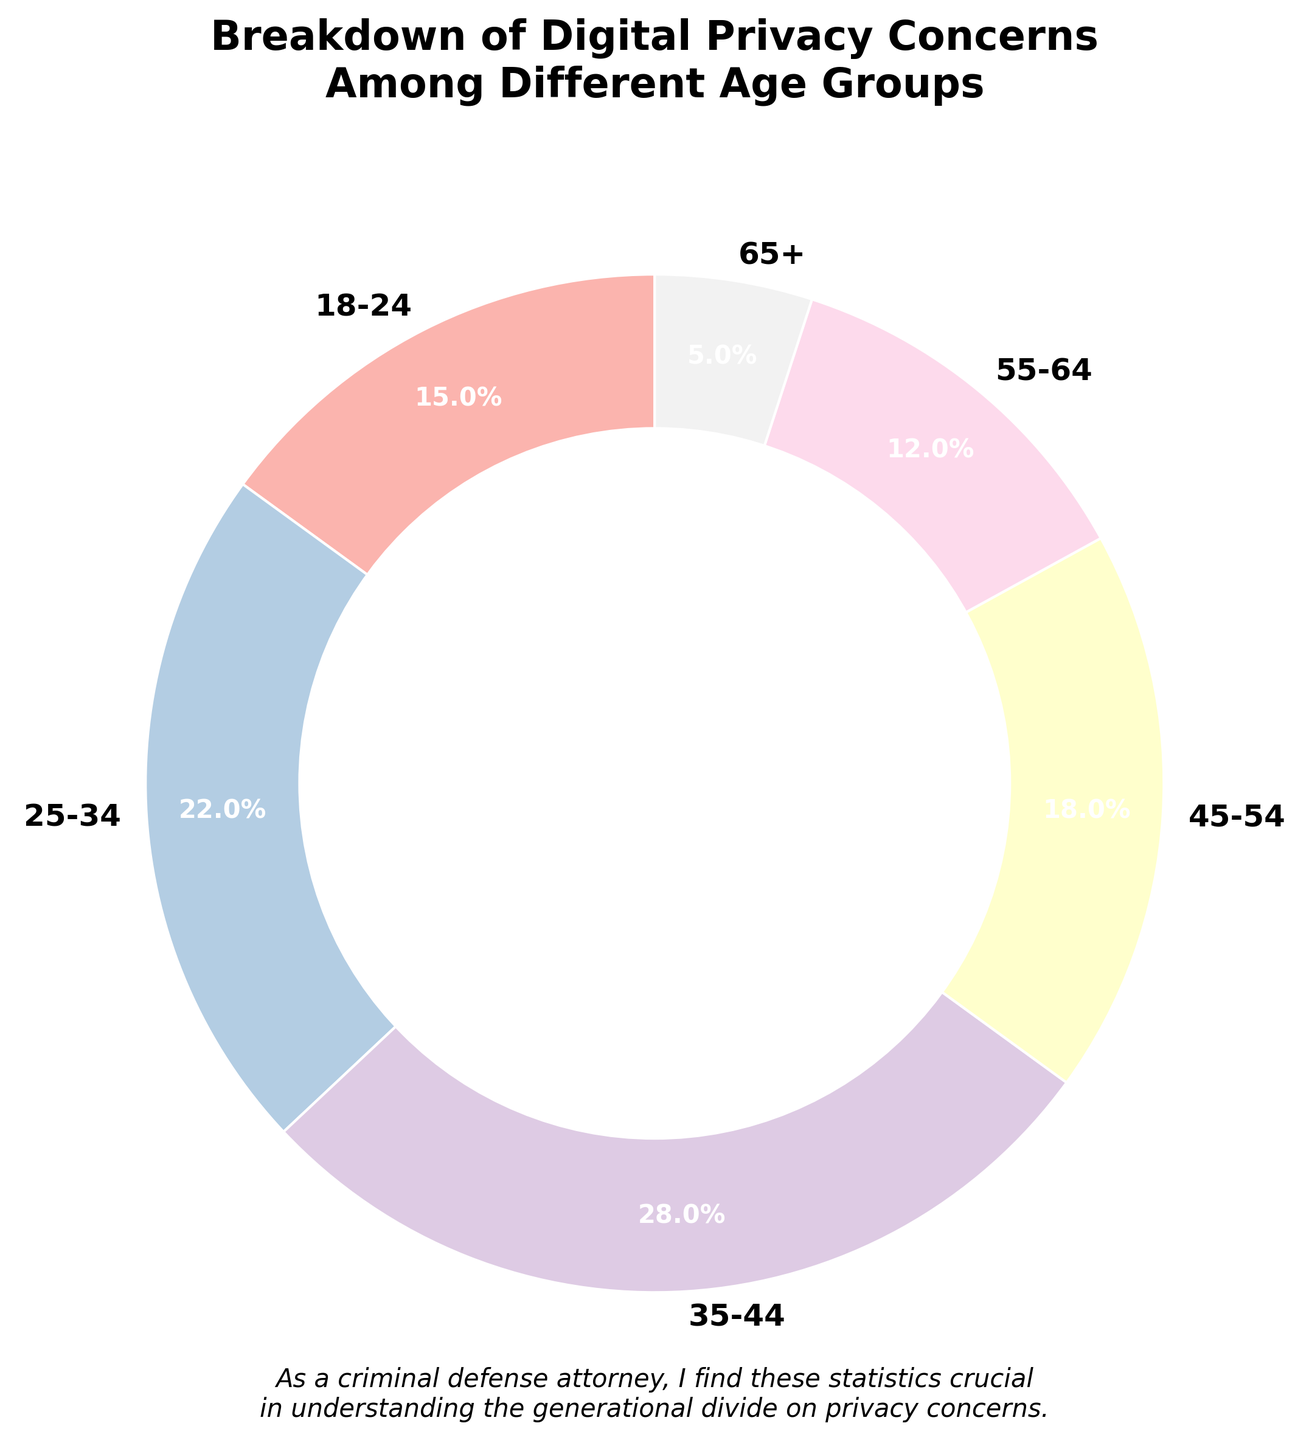What age group shows the highest percentage of digital privacy concerns? The figure shows that the age group 35-44 has the highest percentage, which is labeled as 28%.
Answer: 35-44 Which age group shows the least percentage of digital privacy concerns? The figure indicates that the age group 65+ has the smallest percentage, labeled as 5%.
Answer: 65+ What is the combined percentage of digital privacy concerns for age groups 18-24 and 25-34? The percentage for age group 18-24 is 15%, and for 25-34 it is 22%. Adding them gives 15% + 22% = 37%.
Answer: 37% How does the percentage for the age group 55-64 compare to the age group 45-54? The percentage for age group 55-64 is 12%, while for 45-54 it is 18%. To compare them: 12% < 18%.
Answer: 12% < 18% What is the average percentage of digital privacy concerns across all age groups? Summing up the percentages: 15% + 22% + 28% + 18% + 12% + 5% = 100%. As there are 6 groups, the average is 100% / 6 = 16.67%.
Answer: 16.67% Which age groups collectively form more than half of the total concerns? Adding the highest percentages step-by-step: 28% (35-44) + 22% (25-34) = 50%. Any additional group will make it more than half. Hence, the age groups 25-34 and 35-44 collectively form 50% and adding any other group will exceed half.
Answer: 25-34, 35-44 What is the difference in digital privacy concern percentages between the highest and lowest age groups? The highest percentage is 28% (35-44), and the lowest is 5% (65+). The difference is 28% - 5% = 23%.
Answer: 23% If the 18-24 group had a 3% increase in concerns, what would the new percentage be, and how would it compare to the 25-34 age group percentage? A 3% increase for the 18-24 group would make it 15% + 3% = 18%. This would then be compared to the 25-34 group, which remains at 22%. So, 18% < 22%.
Answer: 18%, less than 22% 